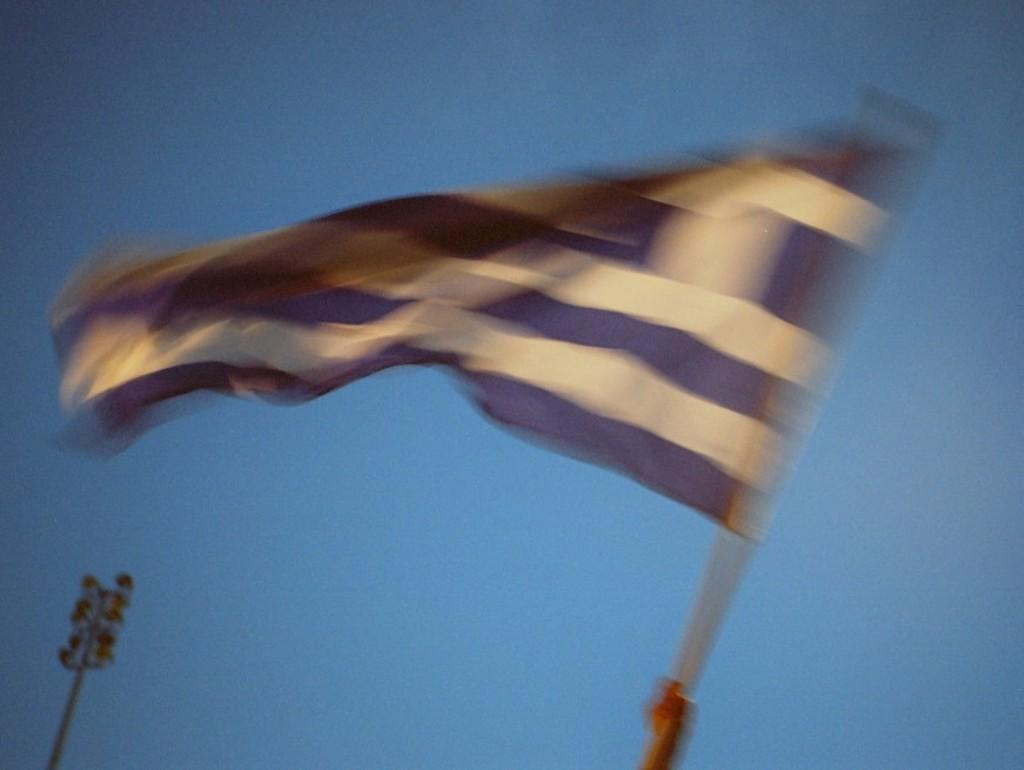What is attached to the pole in the image? There is a flag attached to the pole in the image. What else can be seen on the pole? It appears to be a flood light on the pole. What color is the background of the image? The background of the image has a blue color. What time of day is it in the image, considering the presence of fog? There is no fog present in the image, so it is not possible to determine the time of day based on that factor. 